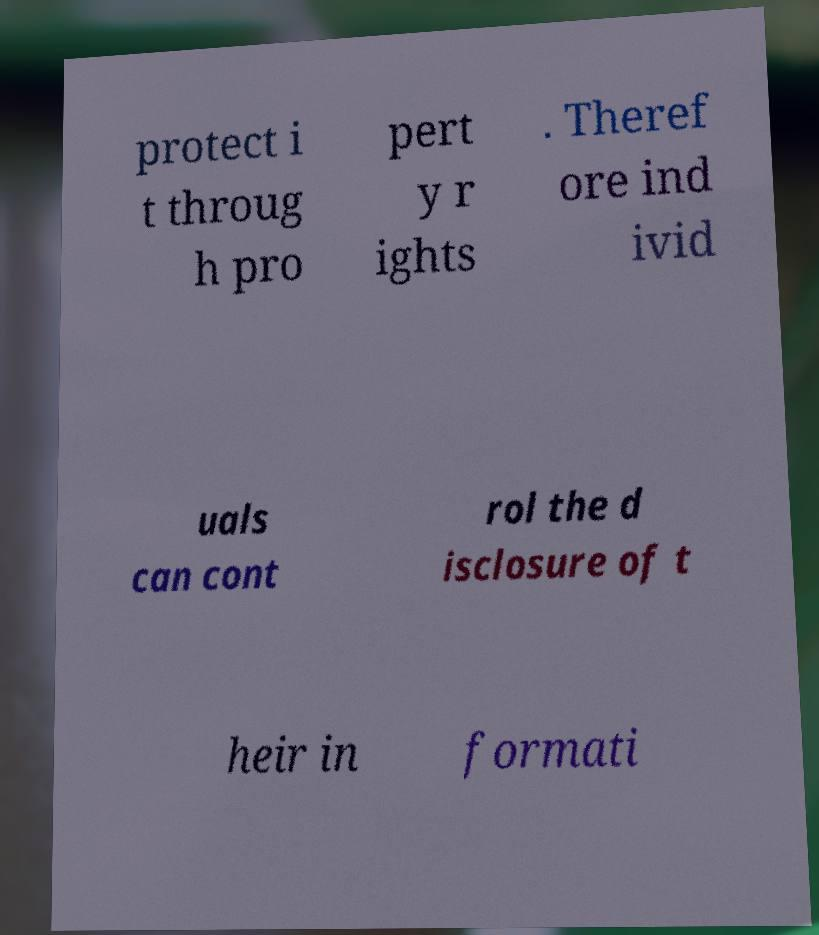For documentation purposes, I need the text within this image transcribed. Could you provide that? protect i t throug h pro pert y r ights . Theref ore ind ivid uals can cont rol the d isclosure of t heir in formati 